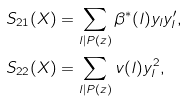Convert formula to latex. <formula><loc_0><loc_0><loc_500><loc_500>S _ { 2 1 } ( X ) & = \sum _ { l | P ( z ) } \beta ^ { * } ( l ) y _ { l } y _ { l } ^ { \prime } , \\ S _ { 2 2 } ( X ) & = \sum _ { l | P ( z ) } v ( l ) y _ { l } ^ { 2 } ,</formula> 